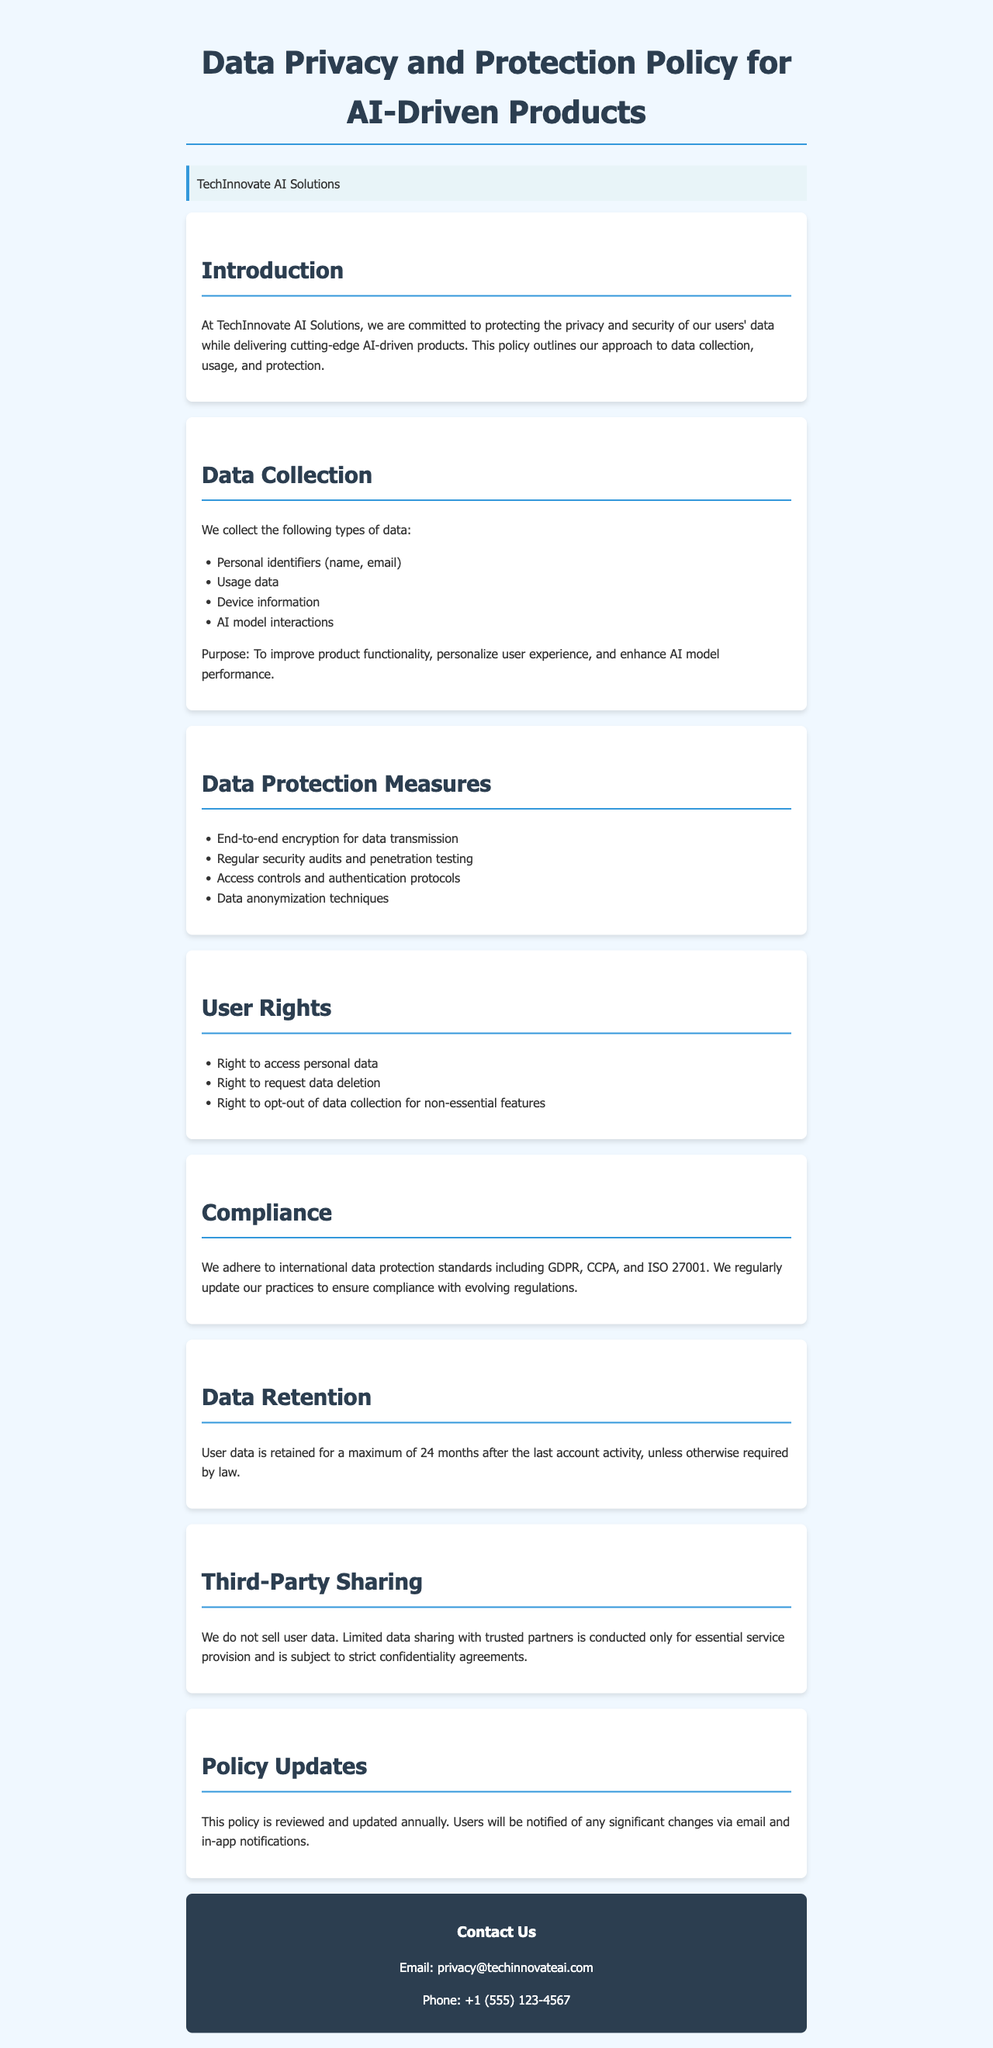What types of data do you collect? The document lists the types of data collected, including personal identifiers and usage data.
Answer: Personal identifiers (name, email), usage data, device information, AI model interactions What is the maximum data retention period? The document states the time limit for retaining user data after the last account activity.
Answer: 24 months Which international data protection standards do you comply with? The document mentions the specific standards with which the startup adheres.
Answer: GDPR, CCPA, ISO 27001 What rights do users have regarding their data? The document outlines specific rights users hold related to their personal data.
Answer: Right to access personal data, right to request data deletion, right to opt-out of data collection for non-essential features What measures are taken to protect data? The document lists various measures to ensure data protection within the organization.
Answer: End-to-end encryption, regular security audits, access controls, data anonymization Is user data sold to third parties? The document explicitly addresses the sharing of user data with other entities.
Answer: No 